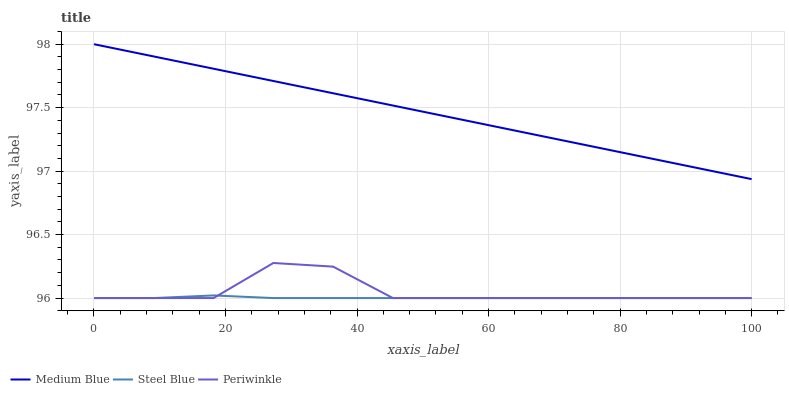Does Steel Blue have the minimum area under the curve?
Answer yes or no. Yes. Does Medium Blue have the maximum area under the curve?
Answer yes or no. Yes. Does Medium Blue have the minimum area under the curve?
Answer yes or no. No. Does Steel Blue have the maximum area under the curve?
Answer yes or no. No. Is Medium Blue the smoothest?
Answer yes or no. Yes. Is Periwinkle the roughest?
Answer yes or no. Yes. Is Steel Blue the smoothest?
Answer yes or no. No. Is Steel Blue the roughest?
Answer yes or no. No. Does Periwinkle have the lowest value?
Answer yes or no. Yes. Does Medium Blue have the lowest value?
Answer yes or no. No. Does Medium Blue have the highest value?
Answer yes or no. Yes. Does Steel Blue have the highest value?
Answer yes or no. No. Is Steel Blue less than Medium Blue?
Answer yes or no. Yes. Is Medium Blue greater than Periwinkle?
Answer yes or no. Yes. Does Steel Blue intersect Periwinkle?
Answer yes or no. Yes. Is Steel Blue less than Periwinkle?
Answer yes or no. No. Is Steel Blue greater than Periwinkle?
Answer yes or no. No. Does Steel Blue intersect Medium Blue?
Answer yes or no. No. 